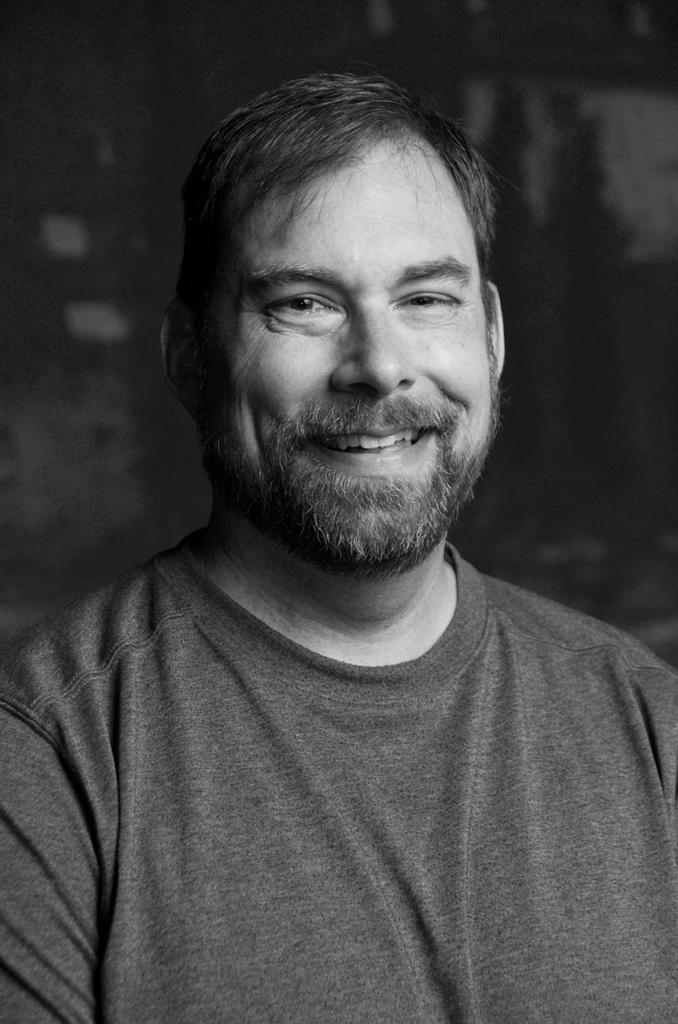What is the color scheme of the image? The image is black and white. Who is present in the image? There is a man in the image. What is the man doing in the image? The man is smiling. Can you describe the background of the image? The background of the image is blurred. What type of feast is the man preparing in the image? There is no feast present in the image; it is a black and white image of a man smiling with a blurred background. 